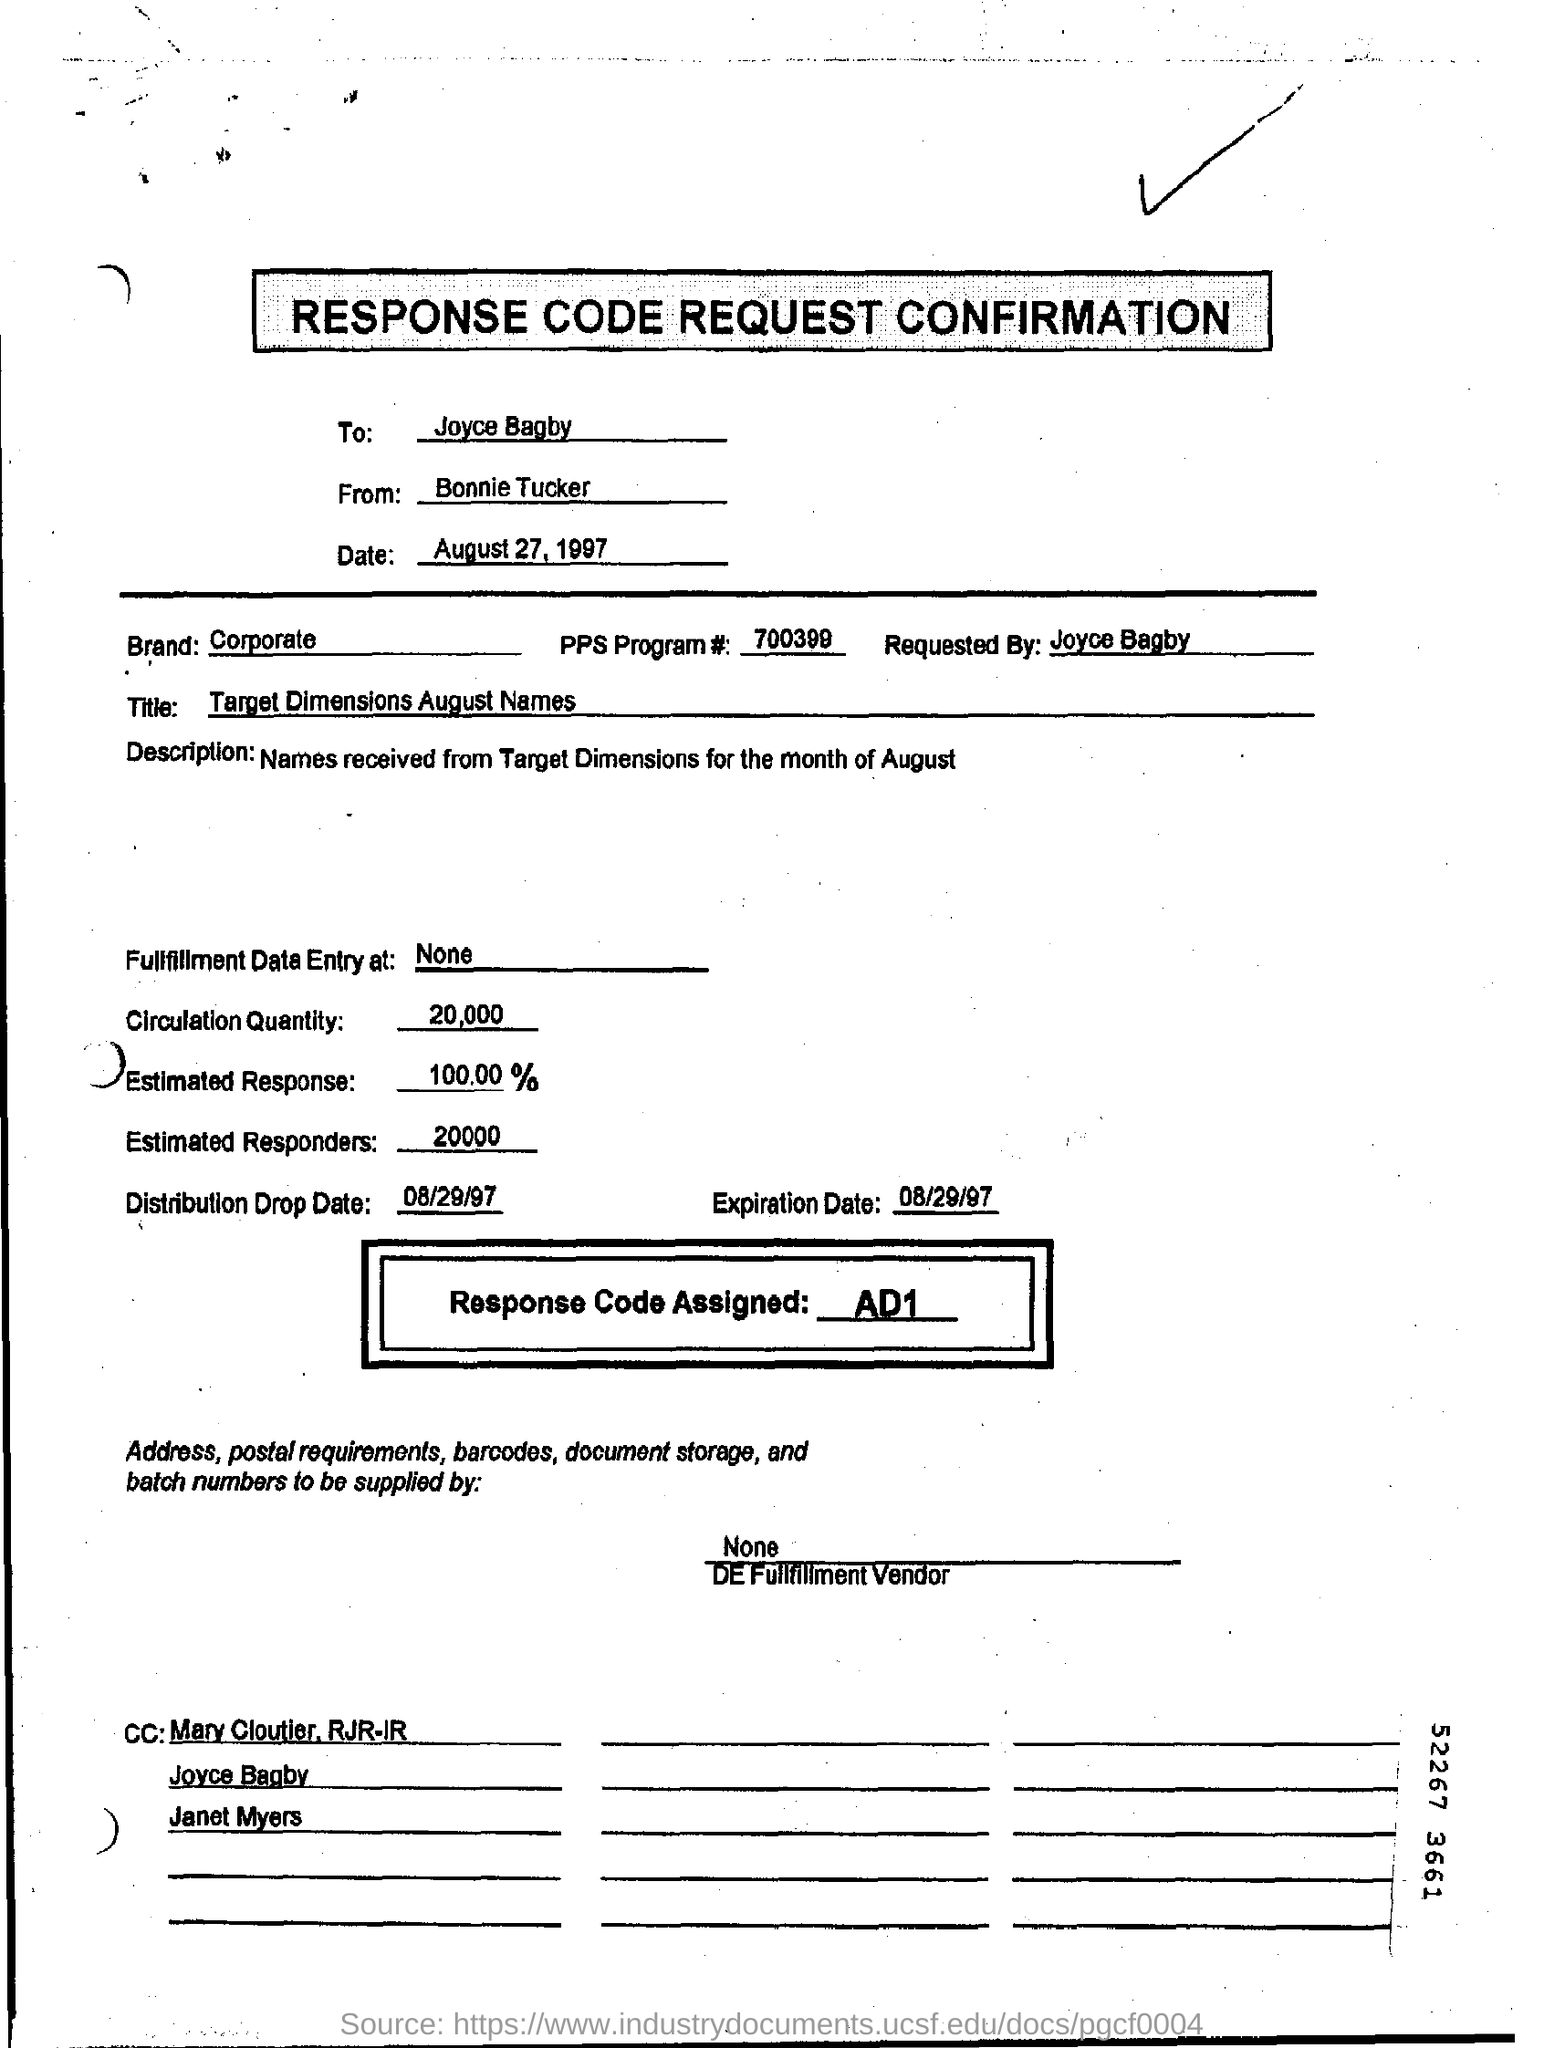List a handful of essential elements in this visual. The question asks about the information entered in the "Brand" field. I'm sorry, but I'm not sure what you are referring to with the phrase "PPS program." Could you please provide more context or information so I can better understand your question and provide a helpful response? The assigned response code is AD1. The individual requesting the confirmation of the response code is Joyce Bagby. The circulation quantity is 20,000. 